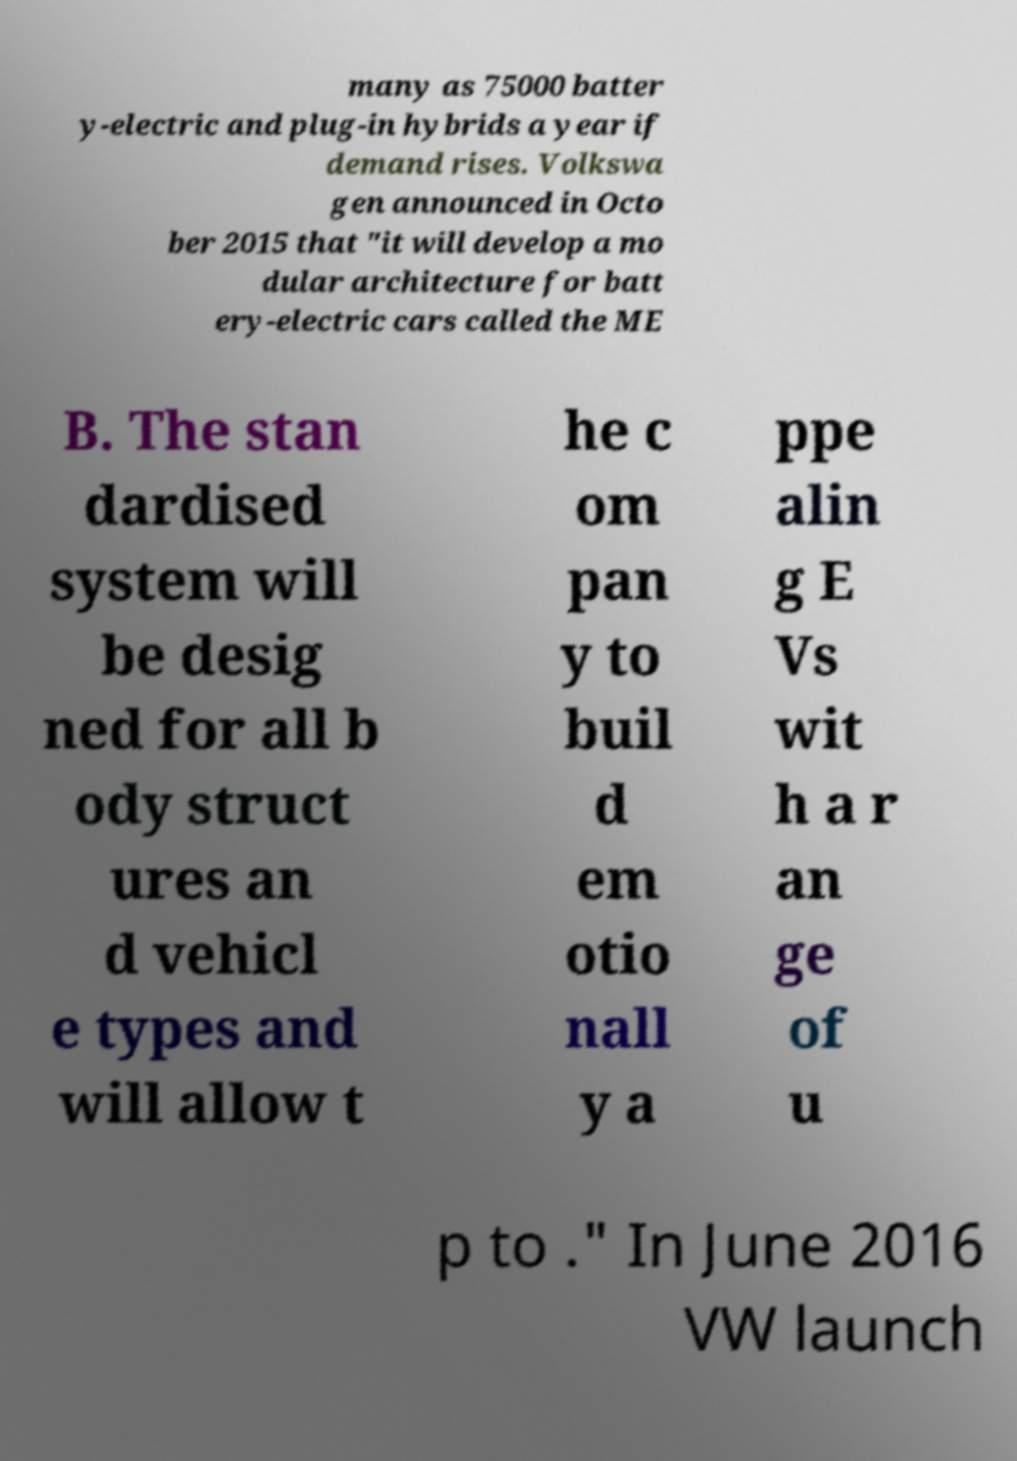For documentation purposes, I need the text within this image transcribed. Could you provide that? many as 75000 batter y-electric and plug-in hybrids a year if demand rises. Volkswa gen announced in Octo ber 2015 that "it will develop a mo dular architecture for batt ery-electric cars called the ME B. The stan dardised system will be desig ned for all b ody struct ures an d vehicl e types and will allow t he c om pan y to buil d em otio nall y a ppe alin g E Vs wit h a r an ge of u p to ." In June 2016 VW launch 